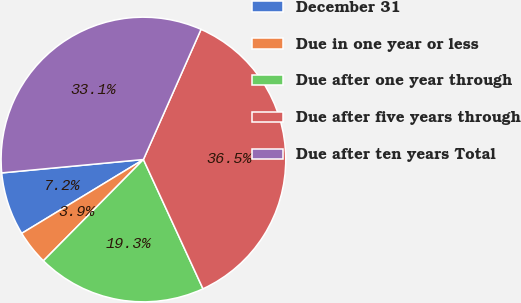Convert chart to OTSL. <chart><loc_0><loc_0><loc_500><loc_500><pie_chart><fcel>December 31<fcel>Due in one year or less<fcel>Due after one year through<fcel>Due after five years through<fcel>Due after ten years Total<nl><fcel>7.18%<fcel>3.92%<fcel>19.27%<fcel>36.49%<fcel>33.13%<nl></chart> 